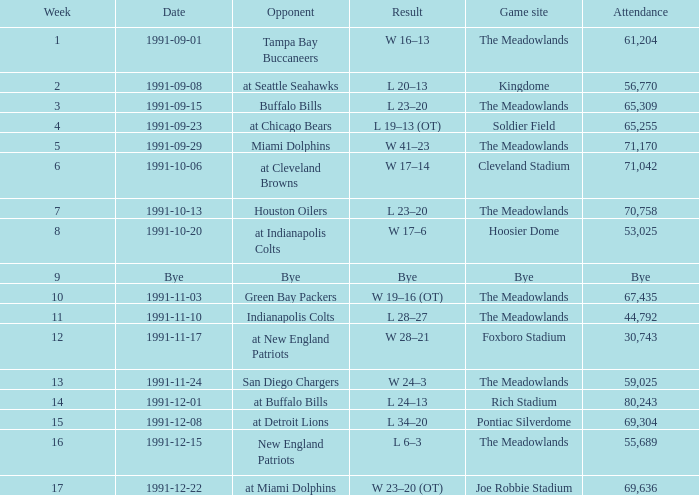Which Opponent was played on 1991-10-13? Houston Oilers. Parse the table in full. {'header': ['Week', 'Date', 'Opponent', 'Result', 'Game site', 'Attendance'], 'rows': [['1', '1991-09-01', 'Tampa Bay Buccaneers', 'W 16–13', 'The Meadowlands', '61,204'], ['2', '1991-09-08', 'at Seattle Seahawks', 'L 20–13', 'Kingdome', '56,770'], ['3', '1991-09-15', 'Buffalo Bills', 'L 23–20', 'The Meadowlands', '65,309'], ['4', '1991-09-23', 'at Chicago Bears', 'L 19–13 (OT)', 'Soldier Field', '65,255'], ['5', '1991-09-29', 'Miami Dolphins', 'W 41–23', 'The Meadowlands', '71,170'], ['6', '1991-10-06', 'at Cleveland Browns', 'W 17–14', 'Cleveland Stadium', '71,042'], ['7', '1991-10-13', 'Houston Oilers', 'L 23–20', 'The Meadowlands', '70,758'], ['8', '1991-10-20', 'at Indianapolis Colts', 'W 17–6', 'Hoosier Dome', '53,025'], ['9', 'Bye', 'Bye', 'Bye', 'Bye', 'Bye'], ['10', '1991-11-03', 'Green Bay Packers', 'W 19–16 (OT)', 'The Meadowlands', '67,435'], ['11', '1991-11-10', 'Indianapolis Colts', 'L 28–27', 'The Meadowlands', '44,792'], ['12', '1991-11-17', 'at New England Patriots', 'W 28–21', 'Foxboro Stadium', '30,743'], ['13', '1991-11-24', 'San Diego Chargers', 'W 24–3', 'The Meadowlands', '59,025'], ['14', '1991-12-01', 'at Buffalo Bills', 'L 24–13', 'Rich Stadium', '80,243'], ['15', '1991-12-08', 'at Detroit Lions', 'L 34–20', 'Pontiac Silverdome', '69,304'], ['16', '1991-12-15', 'New England Patriots', 'L 6–3', 'The Meadowlands', '55,689'], ['17', '1991-12-22', 'at Miami Dolphins', 'W 23–20 (OT)', 'Joe Robbie Stadium', '69,636']]} 